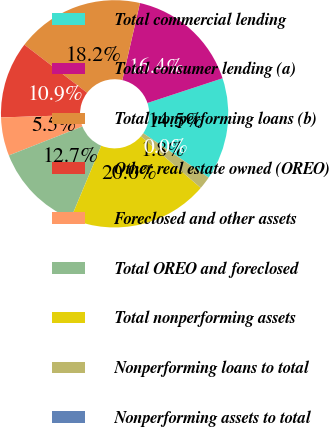<chart> <loc_0><loc_0><loc_500><loc_500><pie_chart><fcel>Total commercial lending<fcel>Total consumer lending (a)<fcel>Total nonperforming loans (b)<fcel>Other real estate owned (OREO)<fcel>Foreclosed and other assets<fcel>Total OREO and foreclosed<fcel>Total nonperforming assets<fcel>Nonperforming loans to total<fcel>Nonperforming assets to total<nl><fcel>14.54%<fcel>16.36%<fcel>18.18%<fcel>10.91%<fcel>5.46%<fcel>12.73%<fcel>20.0%<fcel>1.82%<fcel>0.01%<nl></chart> 